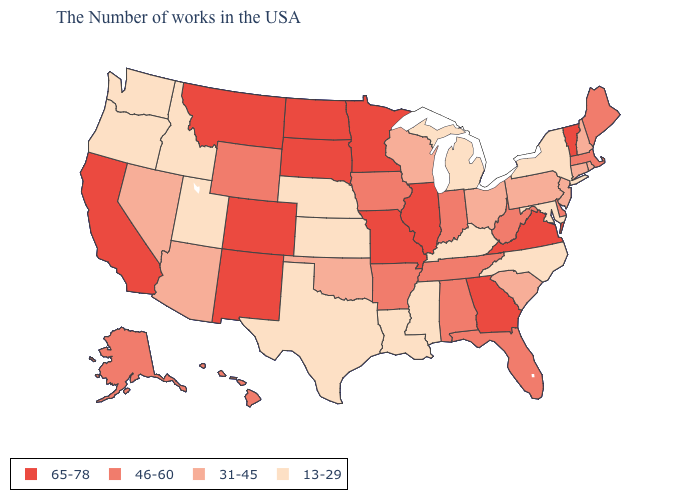What is the lowest value in states that border Louisiana?
Short answer required. 13-29. What is the value of Utah?
Give a very brief answer. 13-29. What is the value of Maryland?
Concise answer only. 13-29. Name the states that have a value in the range 46-60?
Quick response, please. Maine, Massachusetts, Delaware, West Virginia, Florida, Indiana, Alabama, Tennessee, Arkansas, Iowa, Wyoming, Alaska, Hawaii. Does New Hampshire have a lower value than Arizona?
Give a very brief answer. No. What is the value of Idaho?
Quick response, please. 13-29. Name the states that have a value in the range 46-60?
Concise answer only. Maine, Massachusetts, Delaware, West Virginia, Florida, Indiana, Alabama, Tennessee, Arkansas, Iowa, Wyoming, Alaska, Hawaii. Which states have the lowest value in the South?
Keep it brief. Maryland, North Carolina, Kentucky, Mississippi, Louisiana, Texas. What is the highest value in the MidWest ?
Short answer required. 65-78. Among the states that border Oregon , does California have the lowest value?
Short answer required. No. Does Idaho have the highest value in the USA?
Answer briefly. No. Does Arizona have a higher value than Michigan?
Concise answer only. Yes. Which states hav the highest value in the West?
Give a very brief answer. Colorado, New Mexico, Montana, California. Name the states that have a value in the range 31-45?
Answer briefly. Rhode Island, New Hampshire, Connecticut, New Jersey, Pennsylvania, South Carolina, Ohio, Wisconsin, Oklahoma, Arizona, Nevada. Which states have the lowest value in the USA?
Keep it brief. New York, Maryland, North Carolina, Michigan, Kentucky, Mississippi, Louisiana, Kansas, Nebraska, Texas, Utah, Idaho, Washington, Oregon. 